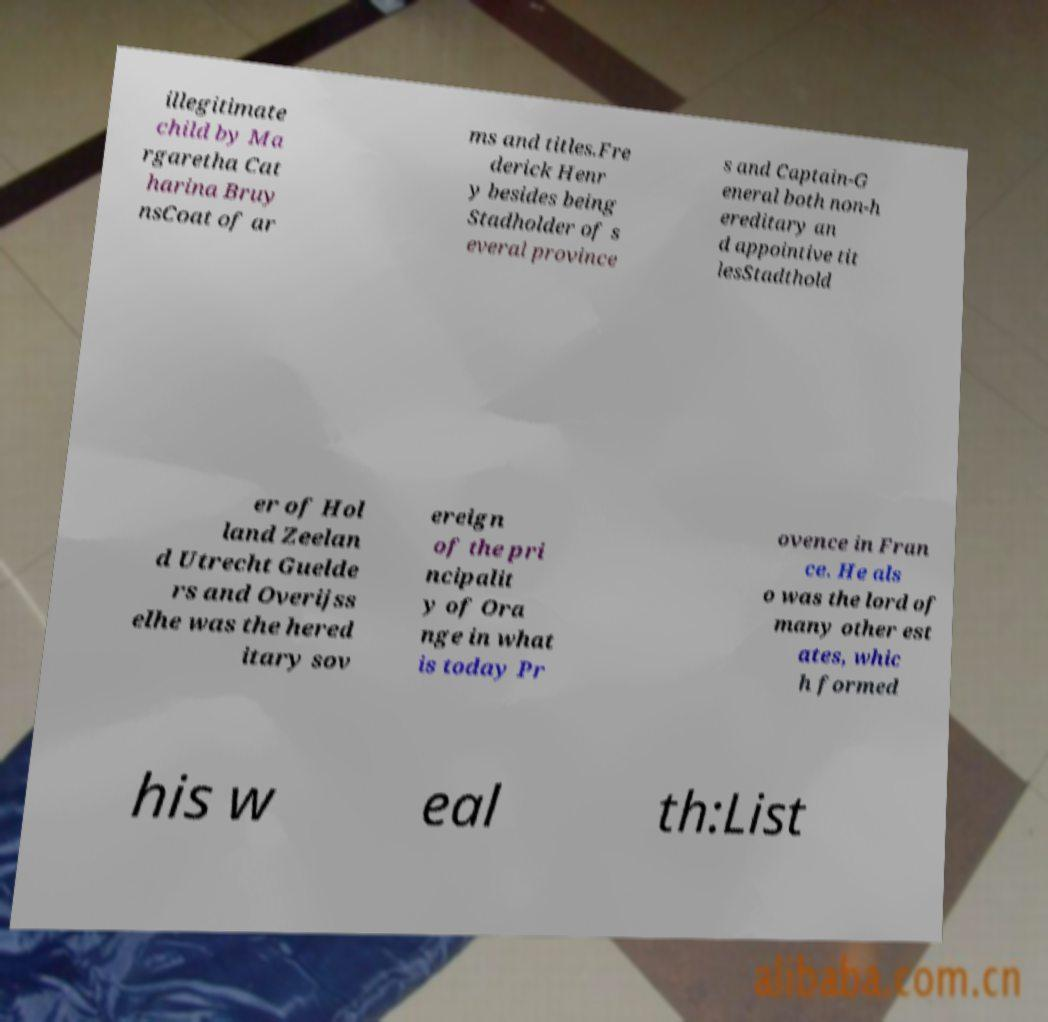Please read and relay the text visible in this image. What does it say? illegitimate child by Ma rgaretha Cat harina Bruy nsCoat of ar ms and titles.Fre derick Henr y besides being Stadholder of s everal province s and Captain-G eneral both non-h ereditary an d appointive tit lesStadthold er of Hol land Zeelan d Utrecht Guelde rs and Overijss elhe was the hered itary sov ereign of the pri ncipalit y of Ora nge in what is today Pr ovence in Fran ce. He als o was the lord of many other est ates, whic h formed his w eal th:List 